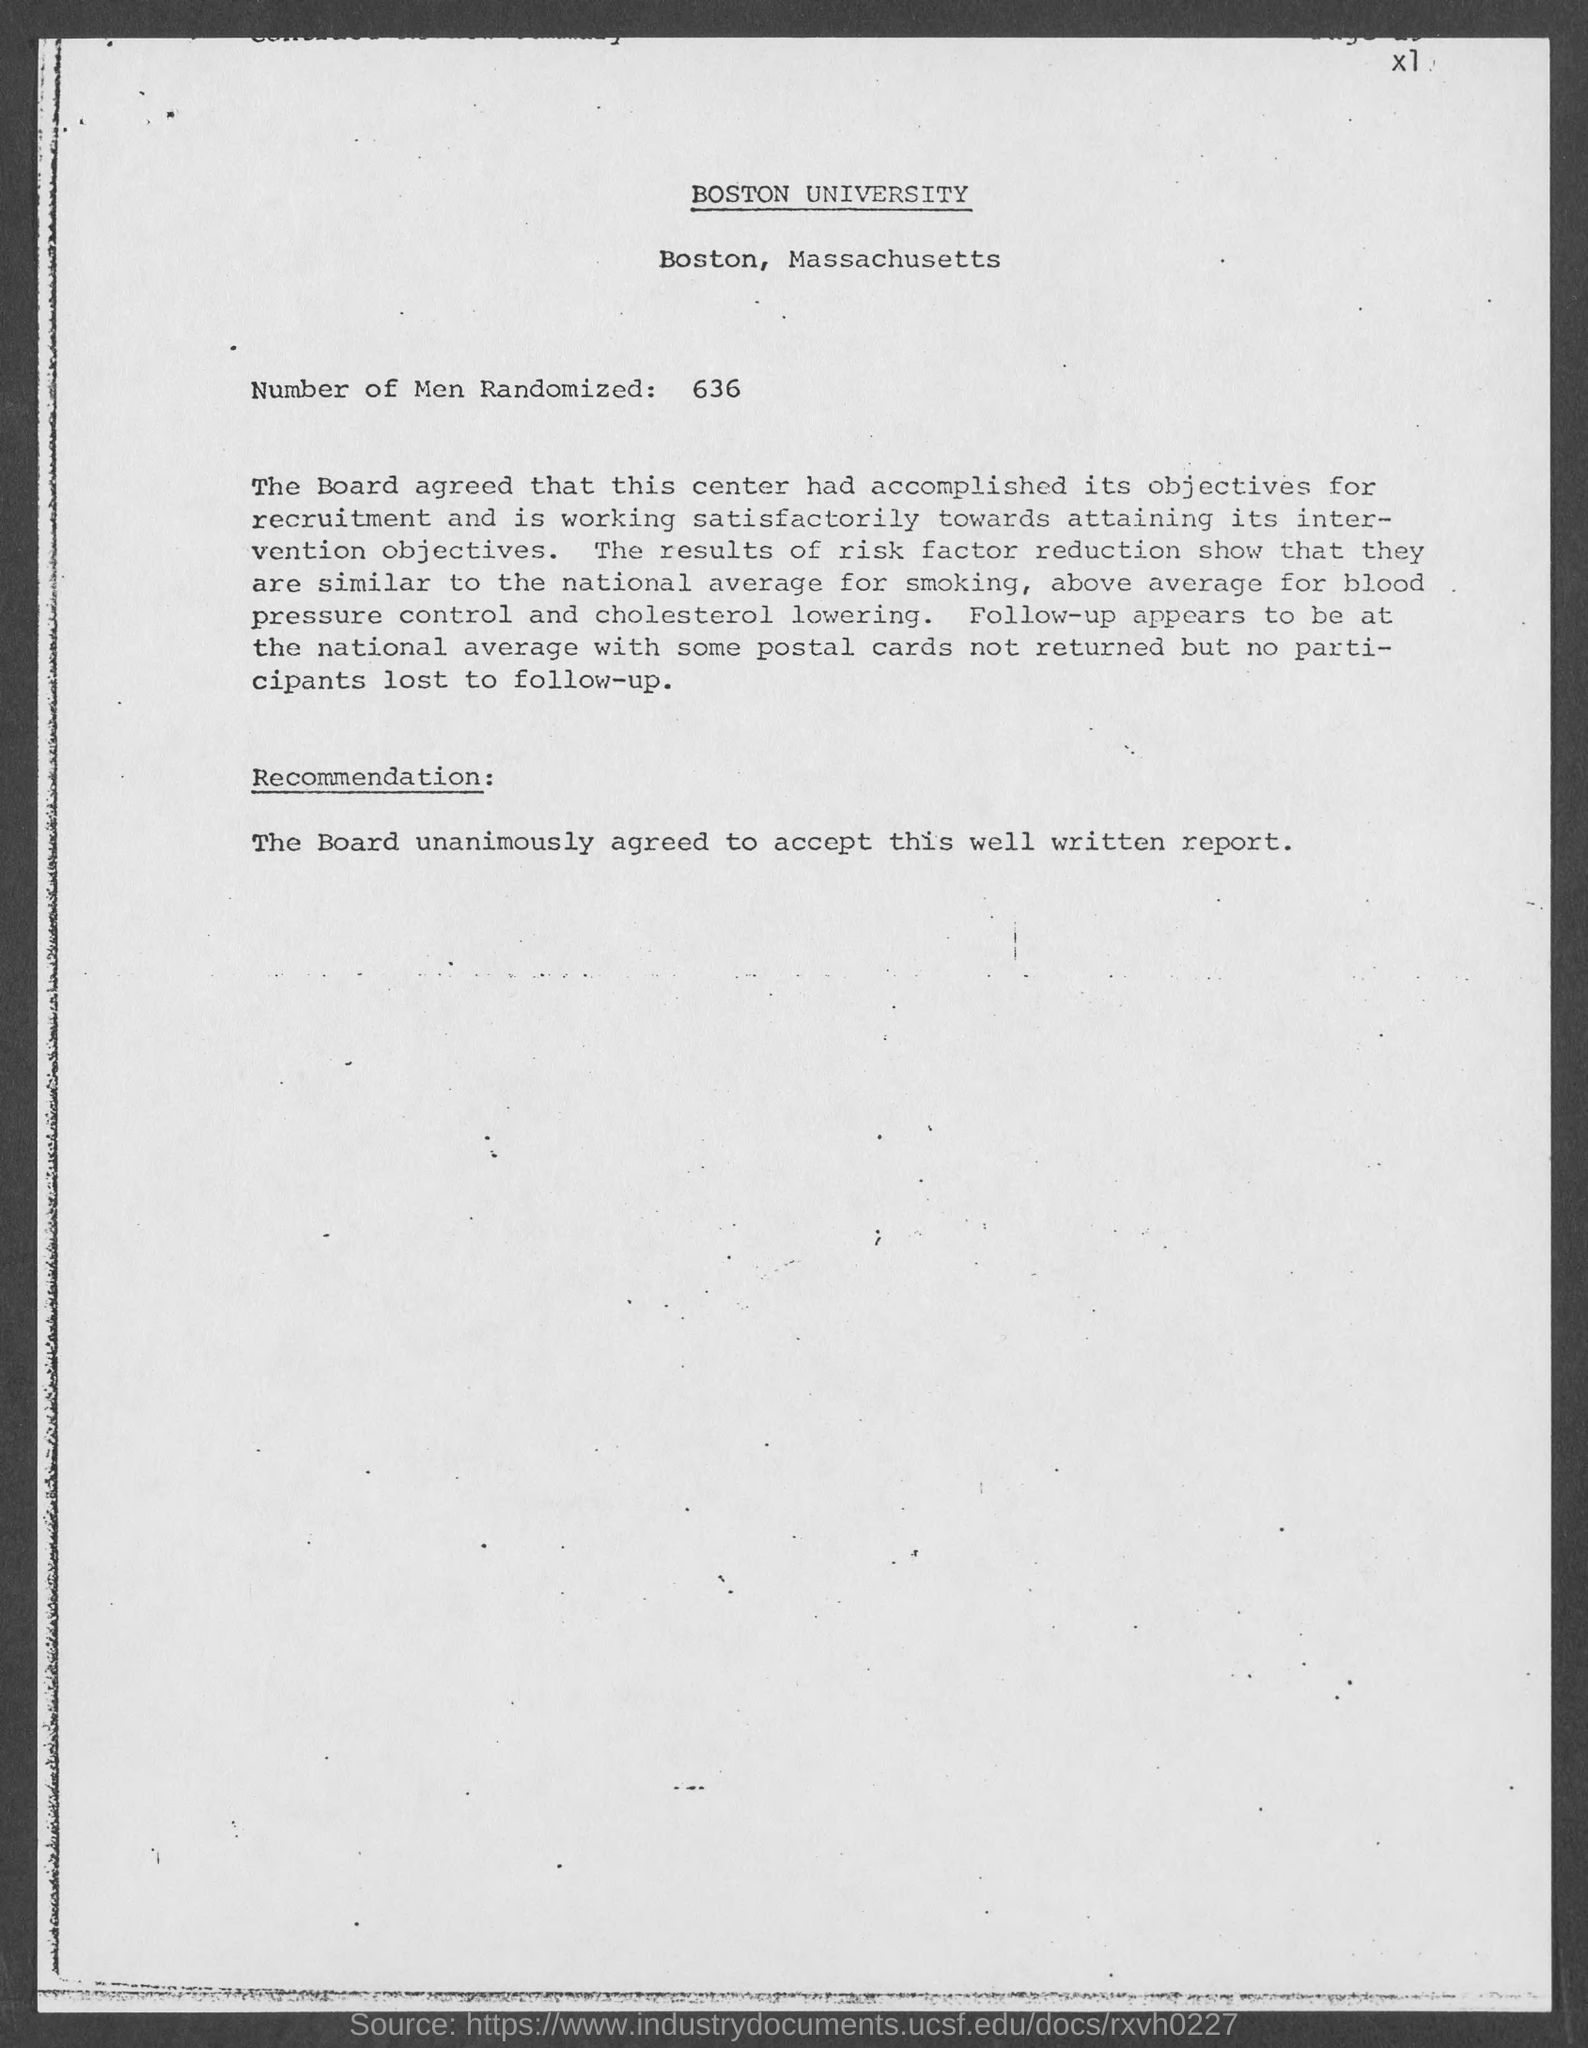Point out several critical features in this image. The location of Boston University is in the state of Massachusetts. 636 participants were randomly selected for the study. 